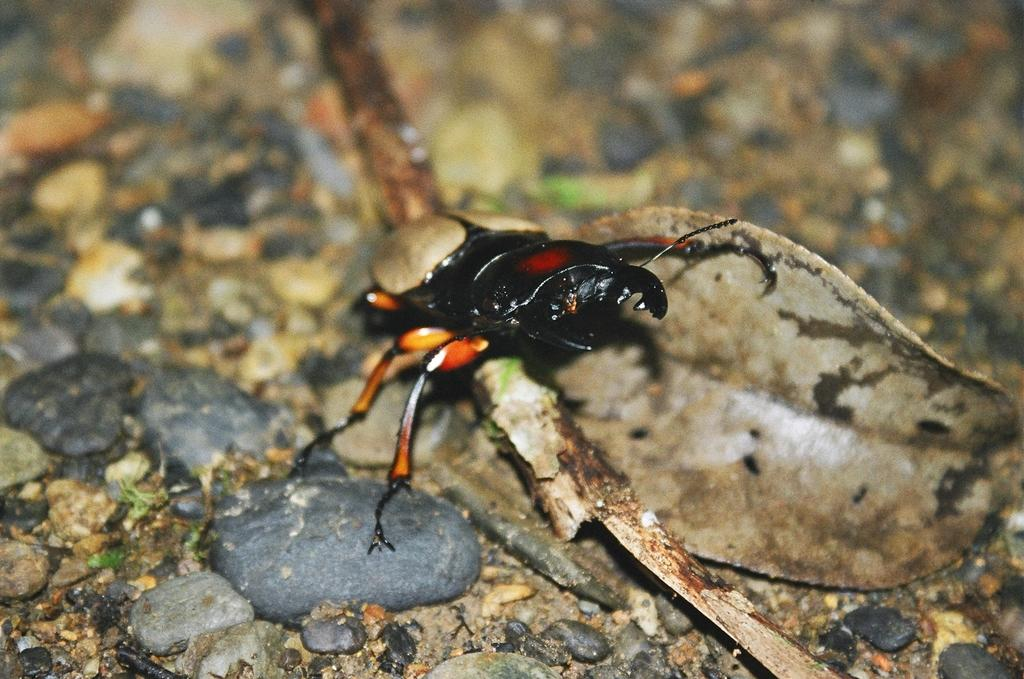Where was the image taken? The image is taken outdoors. What can be seen at the bottom of the image? There is a ground with pebbles and dry leaves at the bottom of the image. What is the main subject in the middle of the image? There is an insect in the middle of the image. What type of attraction is the governor visiting in the image? There is no attraction or governor present in the image; it features an insect and a ground with pebbles and dry leaves. What type of rat can be seen interacting with the insect in the image? There is no rat present in the image; it only features an insect. 